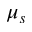<formula> <loc_0><loc_0><loc_500><loc_500>\mu _ { s }</formula> 